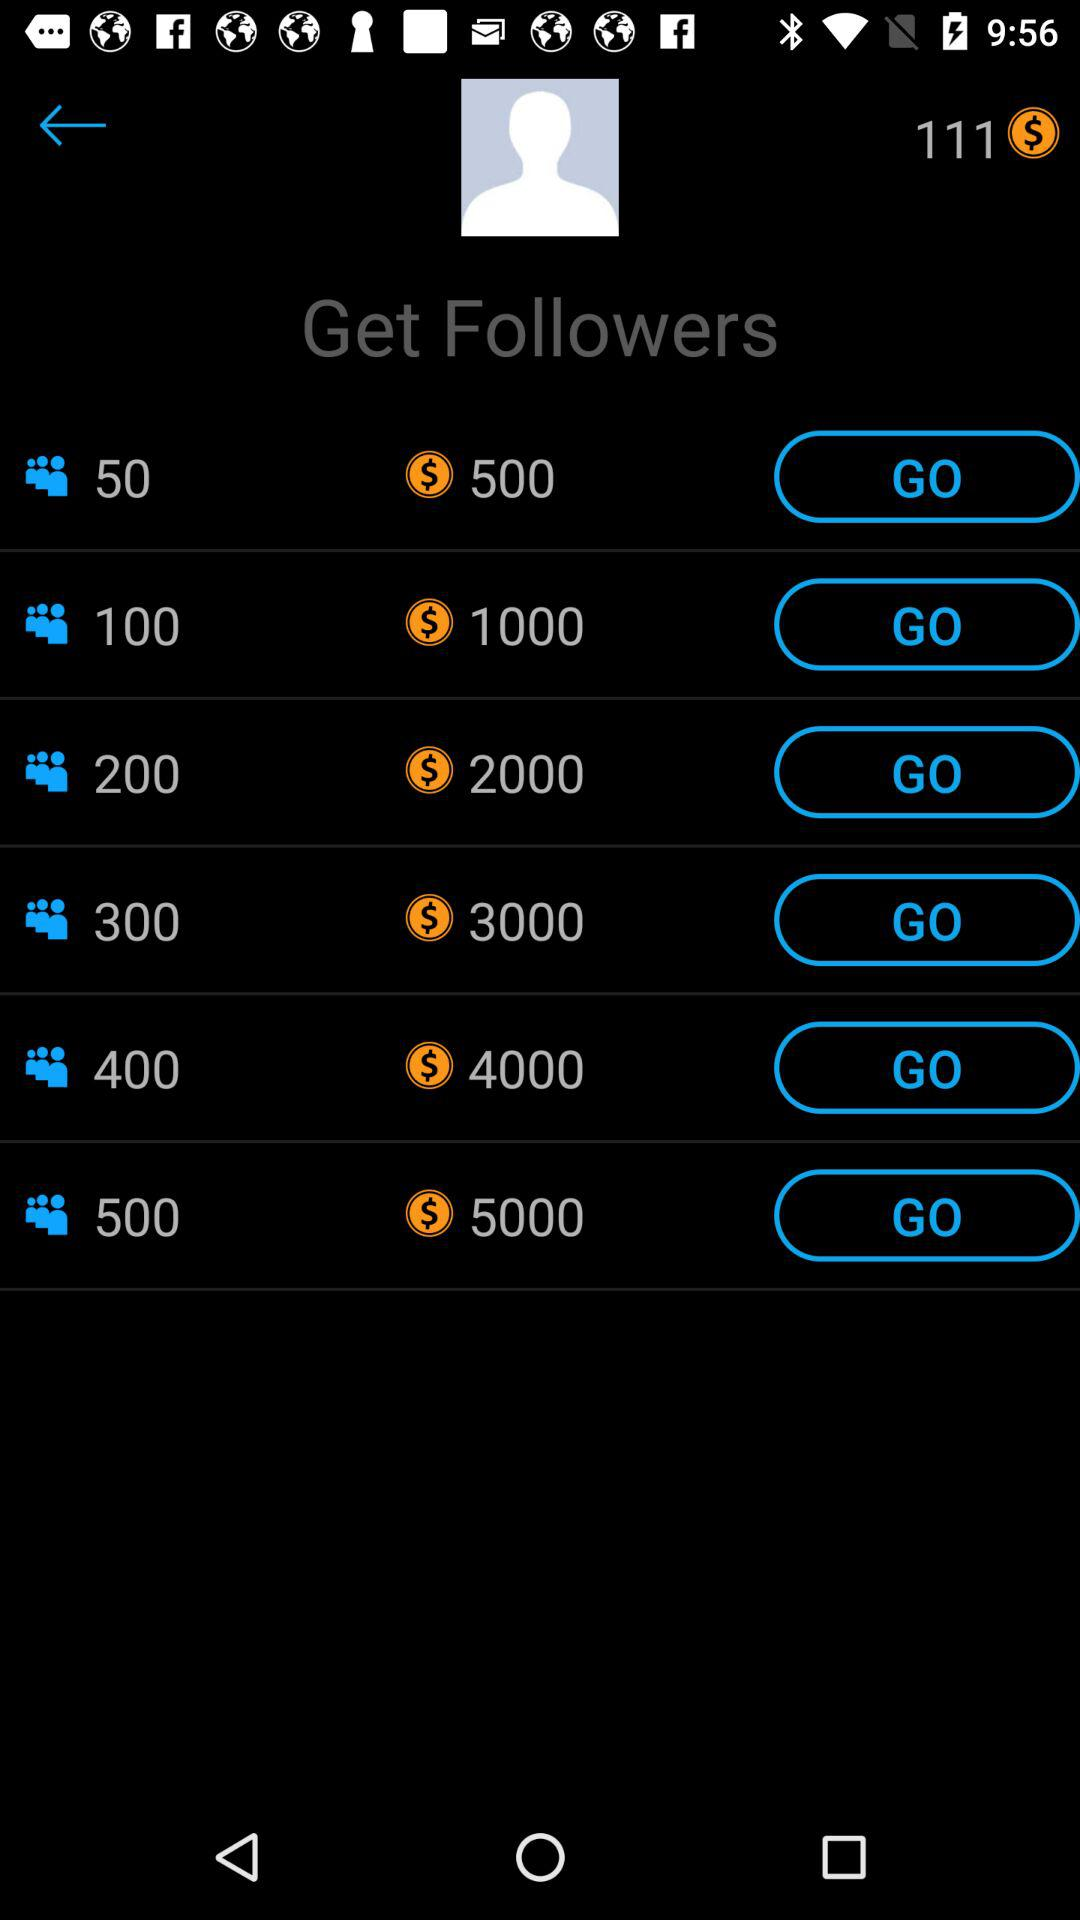How many dollars is the most expensive package?
Answer the question using a single word or phrase. 5000 